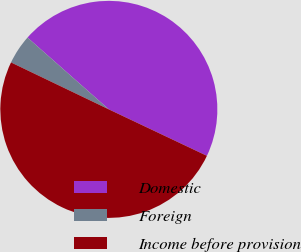Convert chart to OTSL. <chart><loc_0><loc_0><loc_500><loc_500><pie_chart><fcel>Domestic<fcel>Foreign<fcel>Income before provision<nl><fcel>45.53%<fcel>4.39%<fcel>50.08%<nl></chart> 